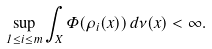<formula> <loc_0><loc_0><loc_500><loc_500>\sup _ { 1 \leq i \leq m } \int _ { X } \Phi ( \rho _ { i } ( x ) ) \, d \nu ( x ) < \infty .</formula> 